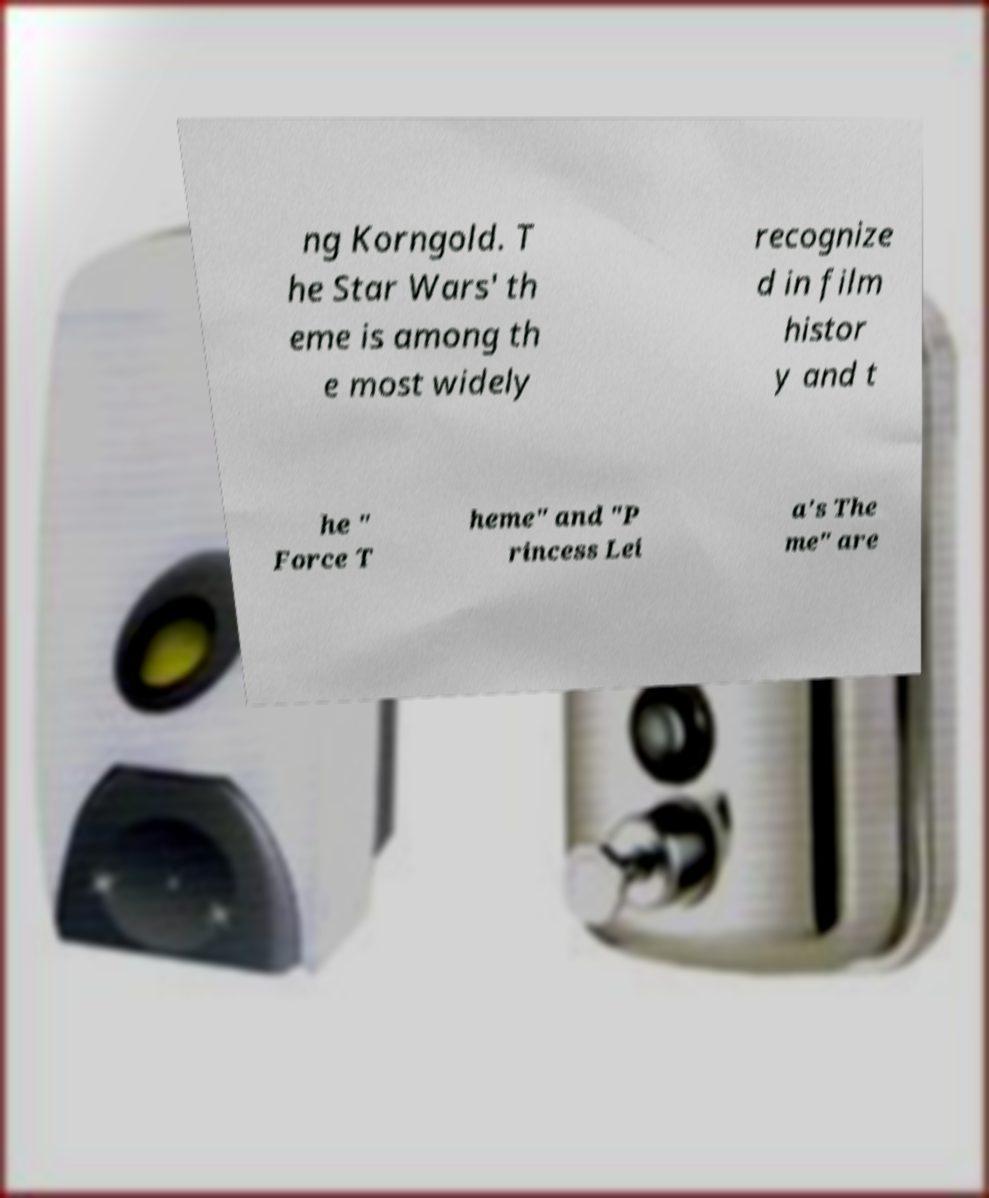Please read and relay the text visible in this image. What does it say? ng Korngold. T he Star Wars' th eme is among th e most widely recognize d in film histor y and t he " Force T heme" and "P rincess Lei a's The me" are 